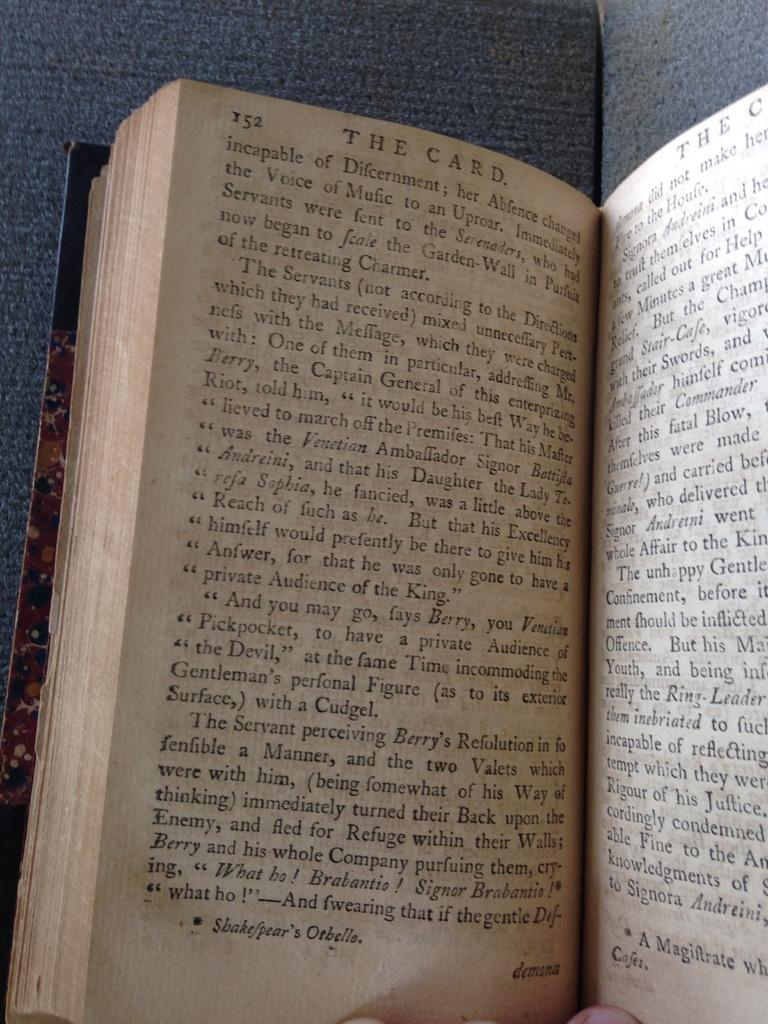<image>
Describe the image concisely. A book is open to page 152 with the heading The Card. 